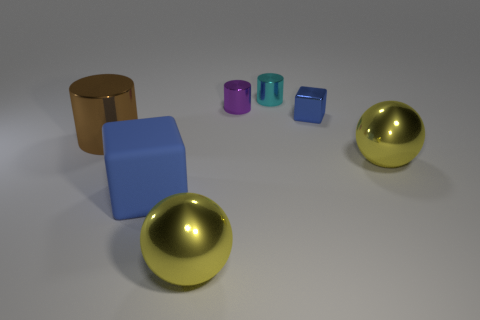What shape is the matte thing that is the same size as the brown metal thing?
Make the answer very short. Cube. Does the block behind the large matte block have the same color as the matte cube?
Your answer should be compact. Yes. What material is the large thing that is both behind the big blue rubber object and right of the large rubber thing?
Offer a very short reply. Metal. Is there a cylinder of the same size as the purple object?
Keep it short and to the point. Yes. What number of gray blocks are there?
Keep it short and to the point. 0. There is a large matte thing; what number of large rubber blocks are behind it?
Offer a terse response. 0. Is the material of the large brown object the same as the big blue thing?
Make the answer very short. No. How many metal things are both in front of the small blue block and to the right of the cyan cylinder?
Make the answer very short. 1. What number of other things are there of the same color as the big block?
Give a very brief answer. 1. How many brown things are big matte cubes or small blocks?
Your answer should be very brief. 0. 